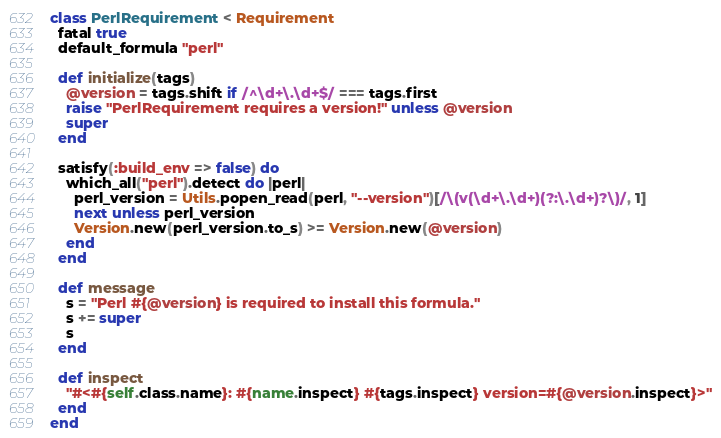Convert code to text. <code><loc_0><loc_0><loc_500><loc_500><_Ruby_>class PerlRequirement < Requirement
  fatal true
  default_formula "perl"

  def initialize(tags)
    @version = tags.shift if /^\d+\.\d+$/ === tags.first
    raise "PerlRequirement requires a version!" unless @version
    super
  end

  satisfy(:build_env => false) do
    which_all("perl").detect do |perl|
      perl_version = Utils.popen_read(perl, "--version")[/\(v(\d+\.\d+)(?:\.\d+)?\)/, 1]
      next unless perl_version
      Version.new(perl_version.to_s) >= Version.new(@version)
    end
  end

  def message
    s = "Perl #{@version} is required to install this formula."
    s += super
    s
  end

  def inspect
    "#<#{self.class.name}: #{name.inspect} #{tags.inspect} version=#{@version.inspect}>"
  end
end
</code> 